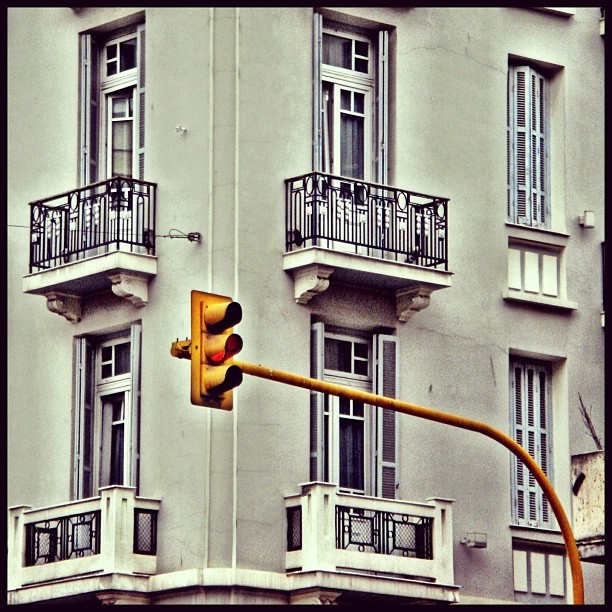Describe the objects in this image and their specific colors. I can see a traffic light in black, orange, brown, and maroon tones in this image. 